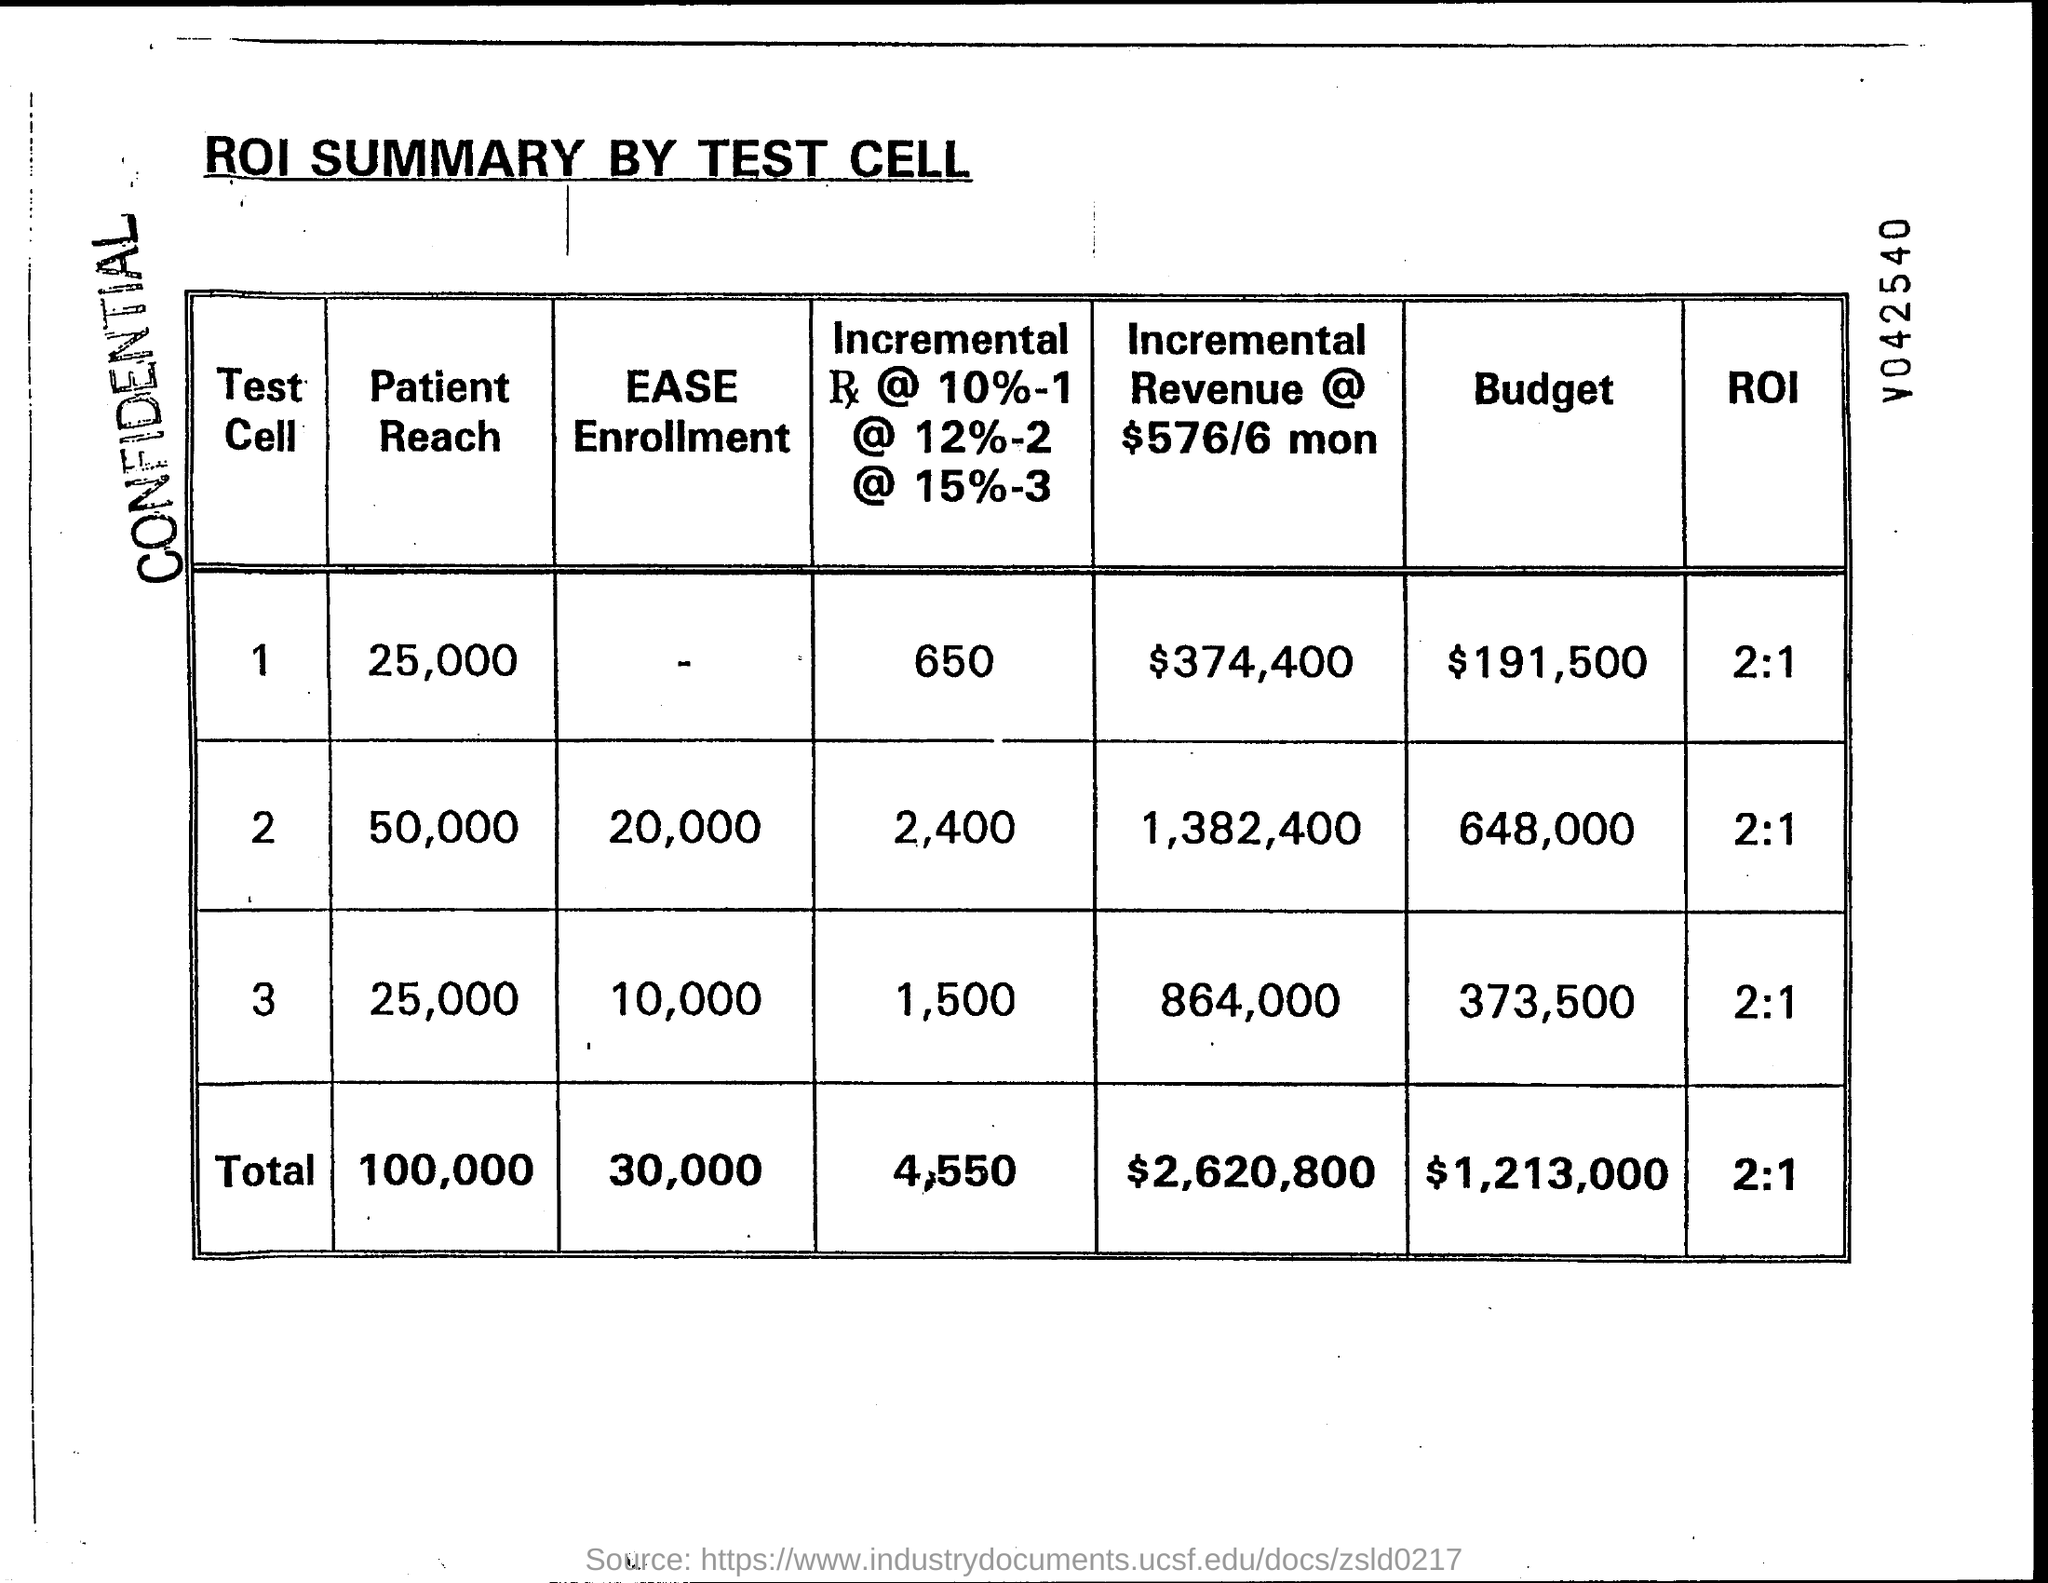what is the total ROI? The total return on investment (ROI) as reported by the ROI SUMMARY BY TEST CELL in the image is 2:1. This indicates for every dollar invested, there is a two-dollar return. 